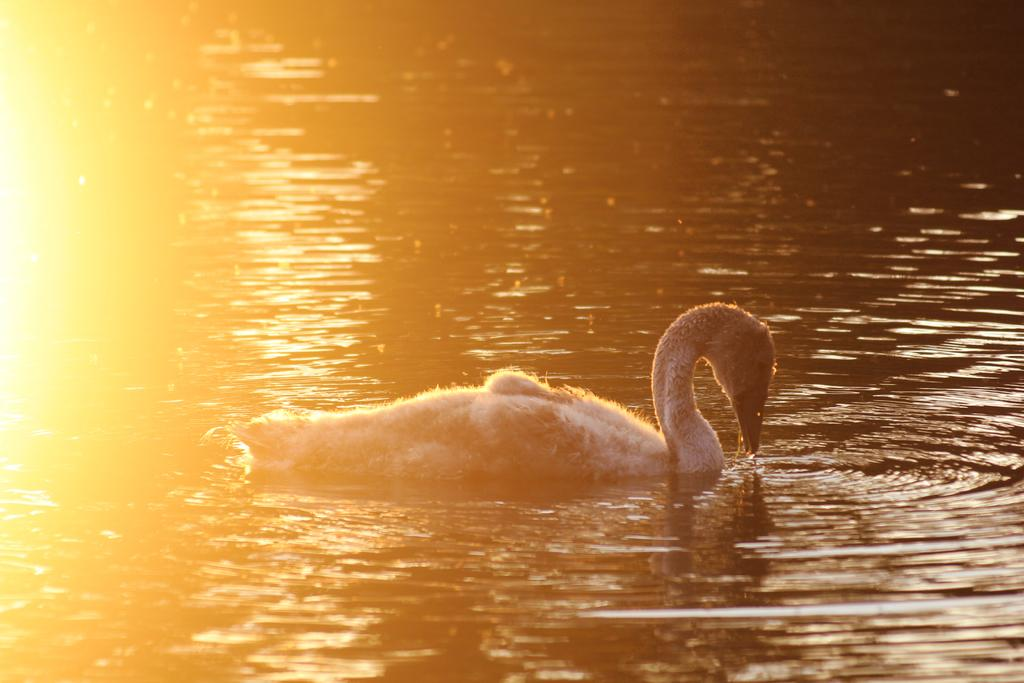What animal is present in the image? There is a duck in the image. Where is the duck located? The duck is in the water. What type of map is the duck using to navigate in the image? There is no map present in the image, and the duck is not navigating. 